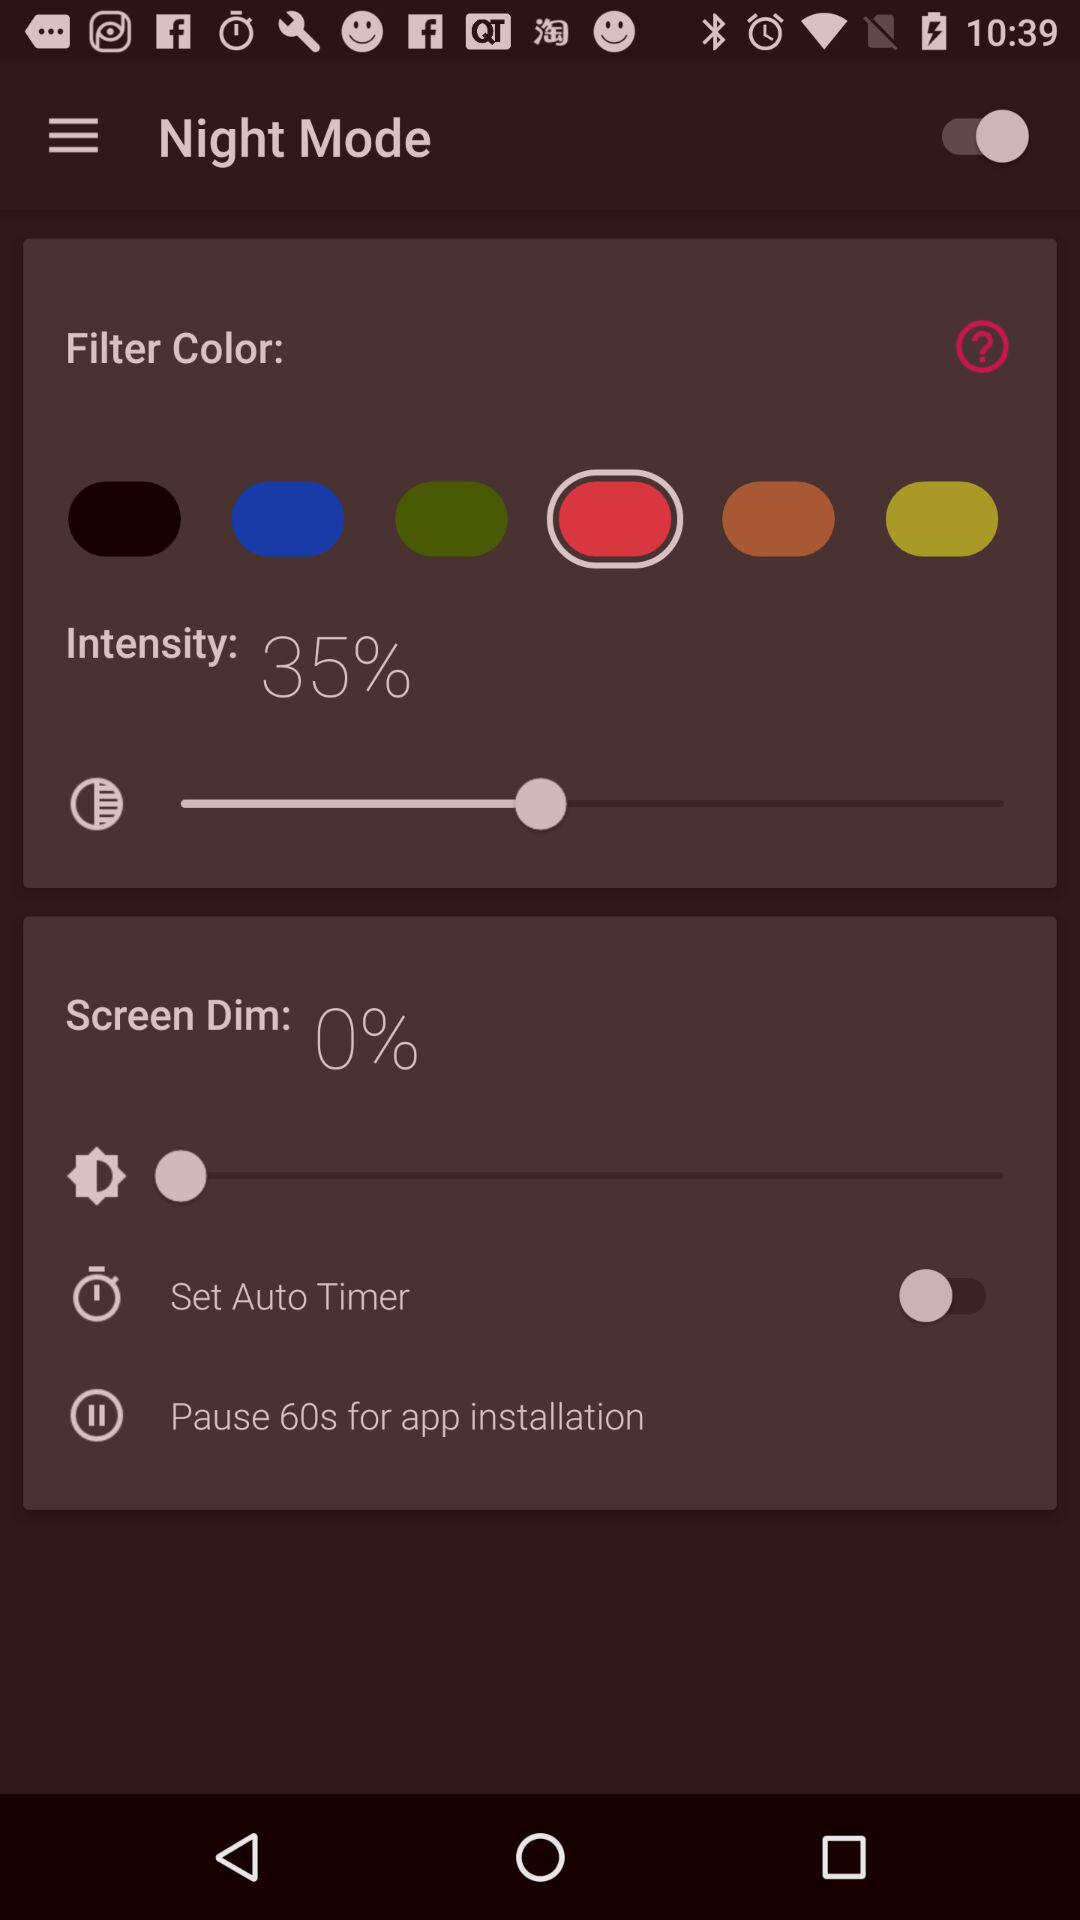What is the intensity percentage? The intensity percentage is 35. 